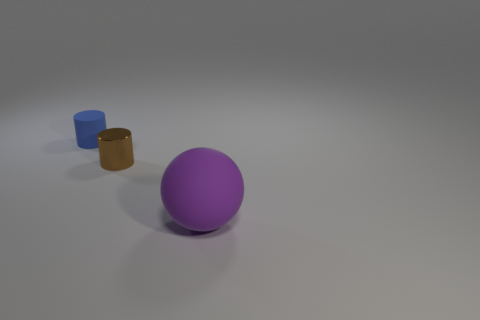Can you describe the lighting in the scene? The lighting in the image is subdued and diffused, providing an even illumination across all objects without producing harsh shadows or highlights. 